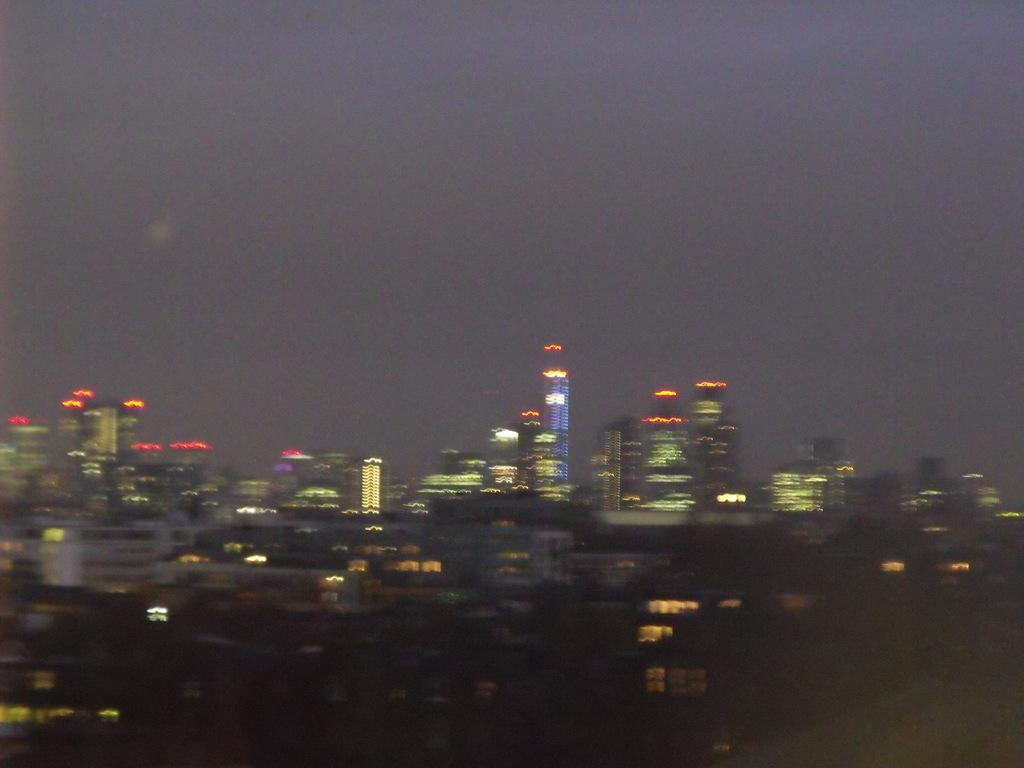What can be observed about the clarity of the image? The view is blurry. What type of structures can be seen in the image? There are many buildings visible. What part of the natural environment is visible in the image? The sky is visible in the image. What type of lipstick is being applied to the wool in the image? There is no lipstick or wool present in the image; it primarily features blurry buildings and the sky. 